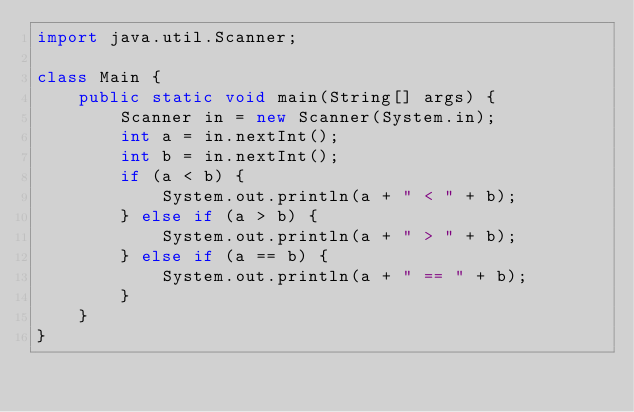<code> <loc_0><loc_0><loc_500><loc_500><_Java_>import java.util.Scanner;

class Main {
	public static void main(String[] args) {
		Scanner in = new Scanner(System.in);
		int a = in.nextInt();
		int b = in.nextInt();
		if (a < b) {
			System.out.println(a + " < " + b);
		} else if (a > b) {
			System.out.println(a + " > " + b);
		} else if (a == b) {
			System.out.println(a + " == " + b);
		}
	}
}</code> 